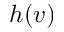<formula> <loc_0><loc_0><loc_500><loc_500>h ( v )</formula> 